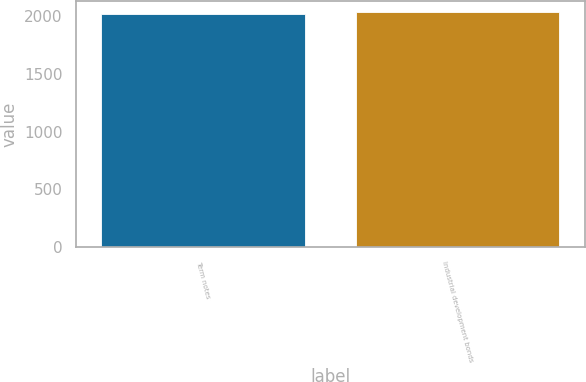Convert chart to OTSL. <chart><loc_0><loc_0><loc_500><loc_500><bar_chart><fcel>Term notes<fcel>Industrial development bonds<nl><fcel>2018<fcel>2030<nl></chart> 